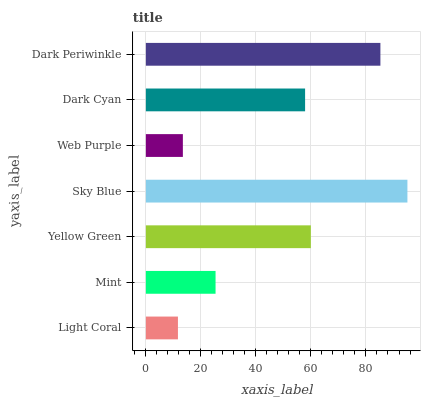Is Light Coral the minimum?
Answer yes or no. Yes. Is Sky Blue the maximum?
Answer yes or no. Yes. Is Mint the minimum?
Answer yes or no. No. Is Mint the maximum?
Answer yes or no. No. Is Mint greater than Light Coral?
Answer yes or no. Yes. Is Light Coral less than Mint?
Answer yes or no. Yes. Is Light Coral greater than Mint?
Answer yes or no. No. Is Mint less than Light Coral?
Answer yes or no. No. Is Dark Cyan the high median?
Answer yes or no. Yes. Is Dark Cyan the low median?
Answer yes or no. Yes. Is Web Purple the high median?
Answer yes or no. No. Is Mint the low median?
Answer yes or no. No. 